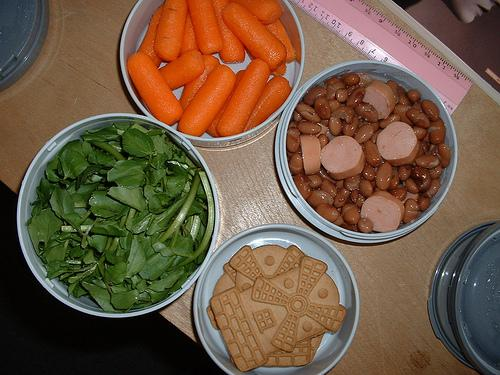What is the cookie in the shape of? Please explain your reasoning. windmill. The cookie has four blades that are attached to a building. 